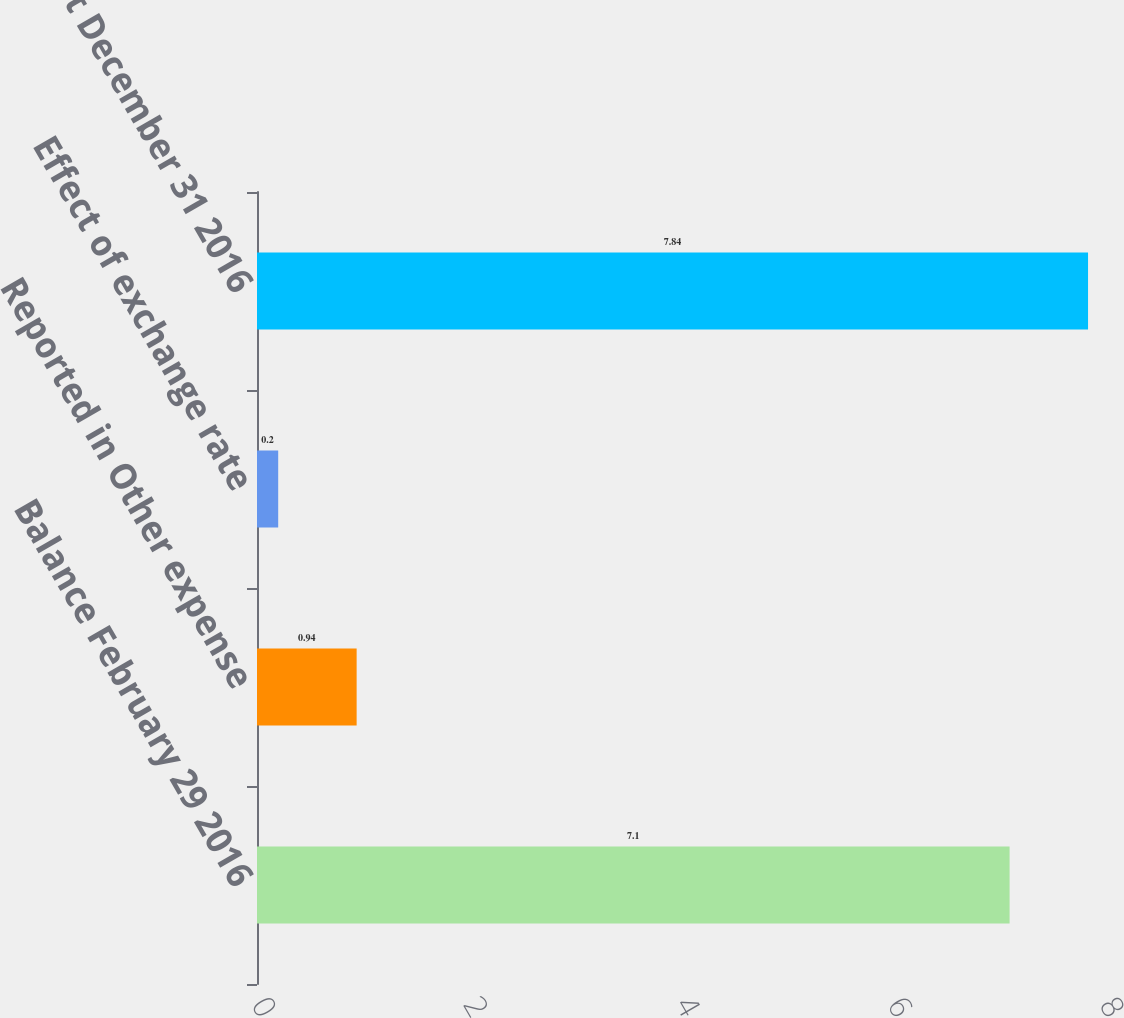Convert chart. <chart><loc_0><loc_0><loc_500><loc_500><bar_chart><fcel>Balance February 29 2016<fcel>Reported in Other expense<fcel>Effect of exchange rate<fcel>Balance at December 31 2016<nl><fcel>7.1<fcel>0.94<fcel>0.2<fcel>7.84<nl></chart> 